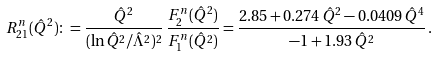<formula> <loc_0><loc_0><loc_500><loc_500>R _ { 2 1 } ^ { n } ( \hat { Q } ^ { 2 } ) \colon = \frac { \hat { Q } ^ { 2 } } { ( \ln \hat { Q } ^ { 2 } / \hat { \Lambda } ^ { 2 } ) ^ { 2 } } \, \frac { F _ { 2 } ^ { n } ( \hat { Q } ^ { 2 } ) } { F _ { 1 } ^ { n } ( \hat { Q } ^ { 2 } ) } = \frac { 2 . 8 5 + 0 . 2 7 4 \, \hat { Q } ^ { 2 } - 0 . 0 4 0 9 \, \hat { Q } ^ { 4 } } { - 1 + 1 . 9 3 \, \hat { Q } ^ { 2 } } \, .</formula> 